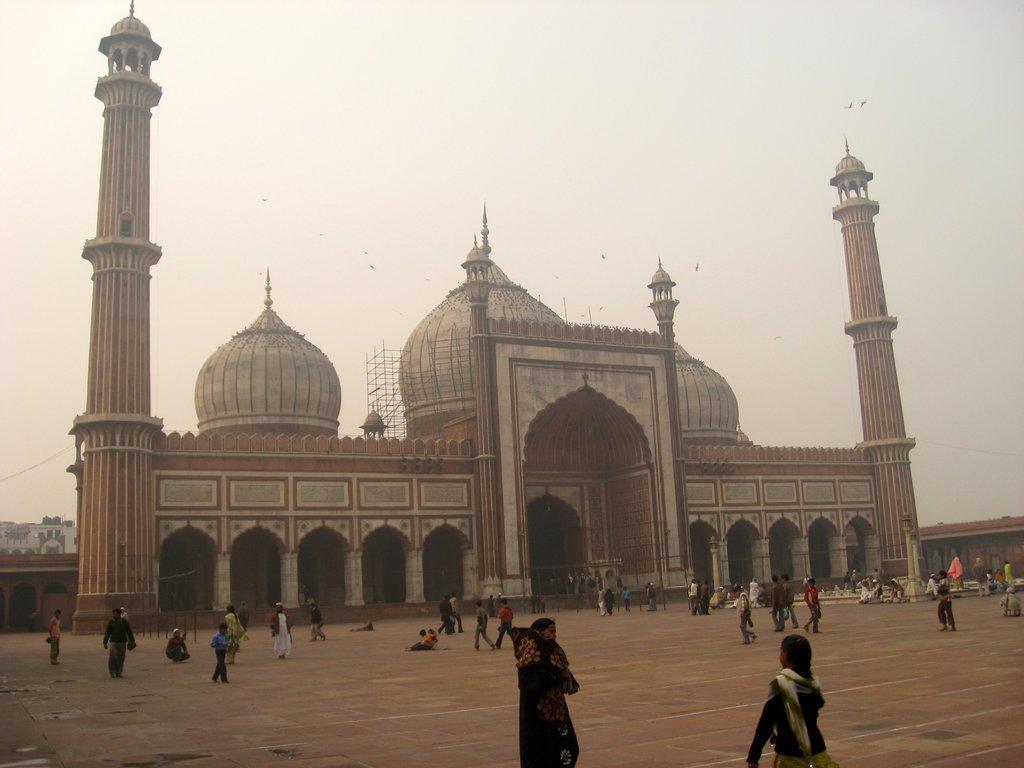How would you summarize this image in a sentence or two? There are people present at the bottom of this image. We can see a building in the middle of this image and the sky is in the background. 